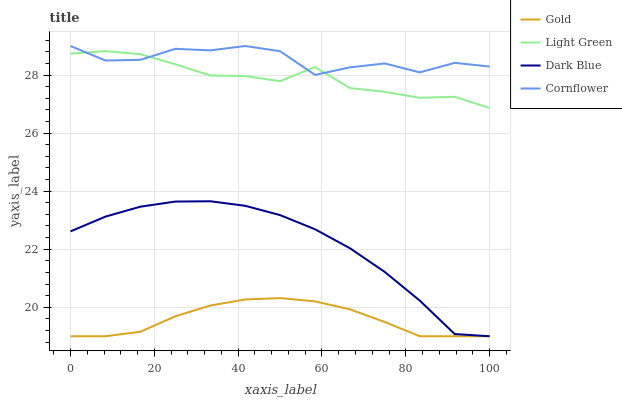Does Gold have the minimum area under the curve?
Answer yes or no. Yes. Does Cornflower have the maximum area under the curve?
Answer yes or no. Yes. Does Light Green have the minimum area under the curve?
Answer yes or no. No. Does Light Green have the maximum area under the curve?
Answer yes or no. No. Is Gold the smoothest?
Answer yes or no. Yes. Is Cornflower the roughest?
Answer yes or no. Yes. Is Light Green the smoothest?
Answer yes or no. No. Is Light Green the roughest?
Answer yes or no. No. Does Light Green have the lowest value?
Answer yes or no. No. Does Cornflower have the highest value?
Answer yes or no. Yes. Does Light Green have the highest value?
Answer yes or no. No. Is Dark Blue less than Cornflower?
Answer yes or no. Yes. Is Cornflower greater than Dark Blue?
Answer yes or no. Yes. Does Gold intersect Dark Blue?
Answer yes or no. Yes. Is Gold less than Dark Blue?
Answer yes or no. No. Is Gold greater than Dark Blue?
Answer yes or no. No. Does Dark Blue intersect Cornflower?
Answer yes or no. No. 